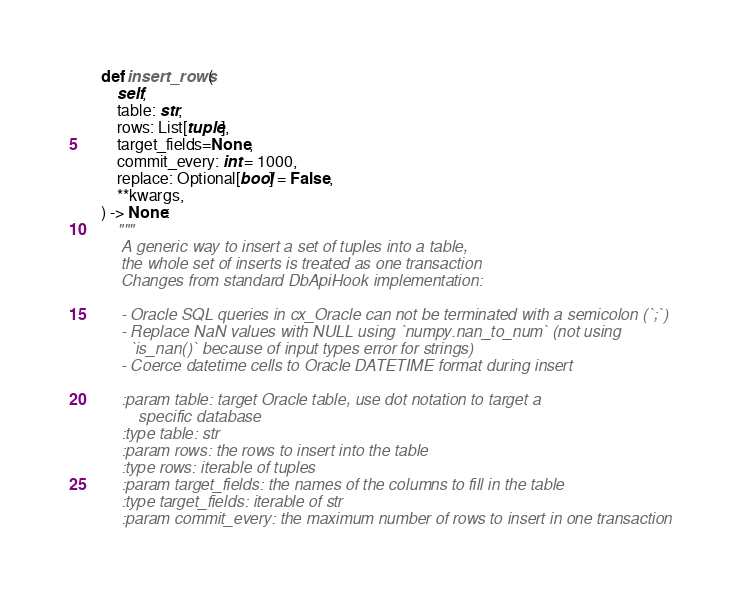<code> <loc_0><loc_0><loc_500><loc_500><_Python_>
    def insert_rows(
        self,
        table: str,
        rows: List[tuple],
        target_fields=None,
        commit_every: int = 1000,
        replace: Optional[bool] = False,
        **kwargs,
    ) -> None:
        """
        A generic way to insert a set of tuples into a table,
        the whole set of inserts is treated as one transaction
        Changes from standard DbApiHook implementation:

        - Oracle SQL queries in cx_Oracle can not be terminated with a semicolon (`;`)
        - Replace NaN values with NULL using `numpy.nan_to_num` (not using
          `is_nan()` because of input types error for strings)
        - Coerce datetime cells to Oracle DATETIME format during insert

        :param table: target Oracle table, use dot notation to target a
            specific database
        :type table: str
        :param rows: the rows to insert into the table
        :type rows: iterable of tuples
        :param target_fields: the names of the columns to fill in the table
        :type target_fields: iterable of str
        :param commit_every: the maximum number of rows to insert in one transaction</code> 